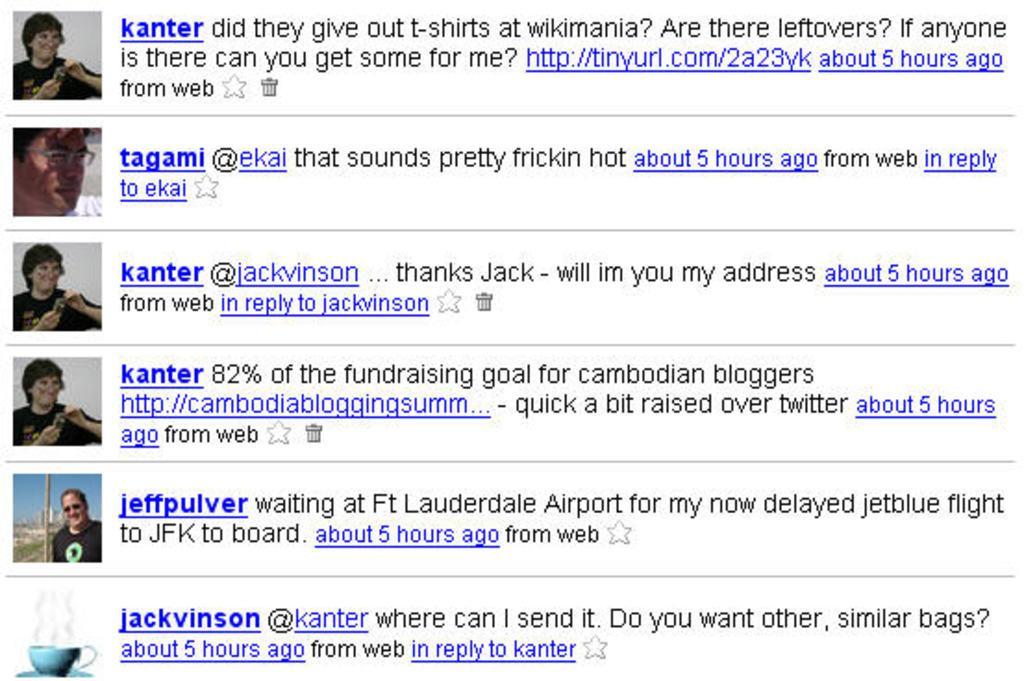In one or two sentences, can you explain what this image depicts? In this picture we can see a screenshot of the twitter account. On the left side see some profile photos from the people. 